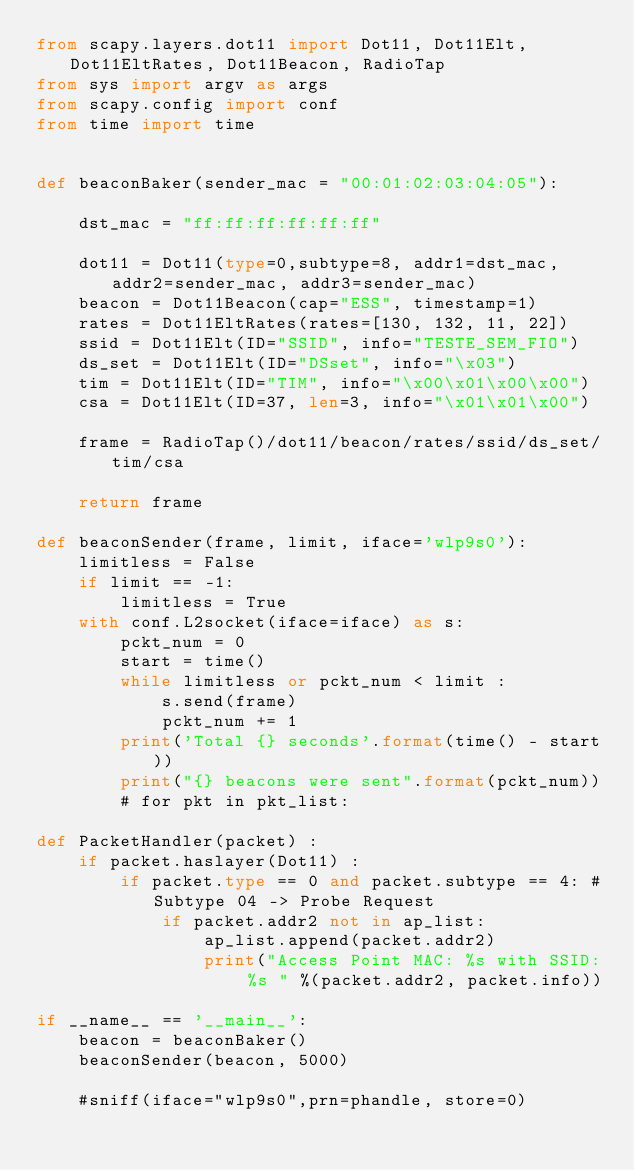Convert code to text. <code><loc_0><loc_0><loc_500><loc_500><_Python_>from scapy.layers.dot11 import Dot11, Dot11Elt, Dot11EltRates, Dot11Beacon, RadioTap
from sys import argv as args
from scapy.config import conf
from time import time


def beaconBaker(sender_mac = "00:01:02:03:04:05"):

    dst_mac = "ff:ff:ff:ff:ff:ff"

    dot11 = Dot11(type=0,subtype=8, addr1=dst_mac, addr2=sender_mac, addr3=sender_mac)
    beacon = Dot11Beacon(cap="ESS", timestamp=1)
    rates = Dot11EltRates(rates=[130, 132, 11, 22])
    ssid = Dot11Elt(ID="SSID", info="TESTE_SEM_FIO")
    ds_set = Dot11Elt(ID="DSset", info="\x03")
    tim = Dot11Elt(ID="TIM", info="\x00\x01\x00\x00")
    csa = Dot11Elt(ID=37, len=3, info="\x01\x01\x00")

    frame = RadioTap()/dot11/beacon/rates/ssid/ds_set/tim/csa

    return frame

def beaconSender(frame, limit, iface='wlp9s0'):
    limitless = False
    if limit == -1:
        limitless = True
    with conf.L2socket(iface=iface) as s:
        pckt_num = 0
        start = time()
        while limitless or pckt_num < limit :
            s.send(frame)
            pckt_num += 1
        print('Total {} seconds'.format(time() - start))
        print("{} beacons were sent".format(pckt_num))
        # for pkt in pkt_list:

def PacketHandler(packet) :
    if packet.haslayer(Dot11) :
        if packet.type == 0 and packet.subtype == 4: #Subtype 04 -> Probe Request
            if packet.addr2 not in ap_list:
                ap_list.append(packet.addr2)
                print("Access Point MAC: %s with SSID: %s " %(packet.addr2, packet.info))

if __name__ == '__main__':
    beacon = beaconBaker()
    beaconSender(beacon, 5000)

    #sniff(iface="wlp9s0",prn=phandle, store=0)</code> 